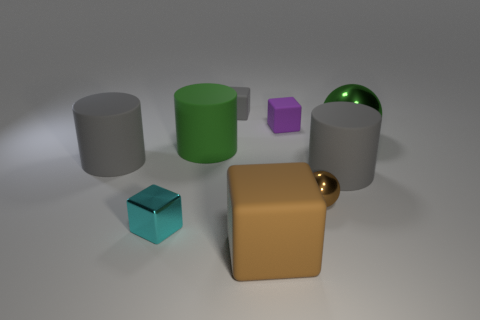Subtract all green spheres. Subtract all green cylinders. How many spheres are left? 1 Subtract all cyan balls. How many brown cubes are left? 1 Subtract all green metal objects. Subtract all small gray things. How many objects are left? 7 Add 4 big metallic spheres. How many big metallic spheres are left? 5 Add 1 tiny yellow cylinders. How many tiny yellow cylinders exist? 1 Subtract all cyan cubes. How many cubes are left? 3 Subtract all big gray matte cylinders. How many cylinders are left? 1 Subtract 0 red balls. How many objects are left? 9 Subtract all cubes. How many objects are left? 5 Subtract 1 spheres. How many spheres are left? 1 